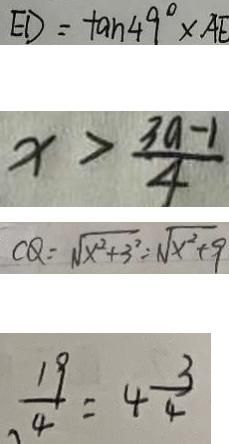<formula> <loc_0><loc_0><loc_500><loc_500>E D = \tan 4 9 ^ { \circ } \times A E 
 x > \frac { 3 a - 1 } { 4 } 
 C Q = \sqrt { x ^ { 2 } + 3 ^ { 2 } } = \sqrt { x ^ { 2 } + 9 } 
 \frac { 1 9 } { 4 } = 4 \frac { 3 } { 4 }</formula> 